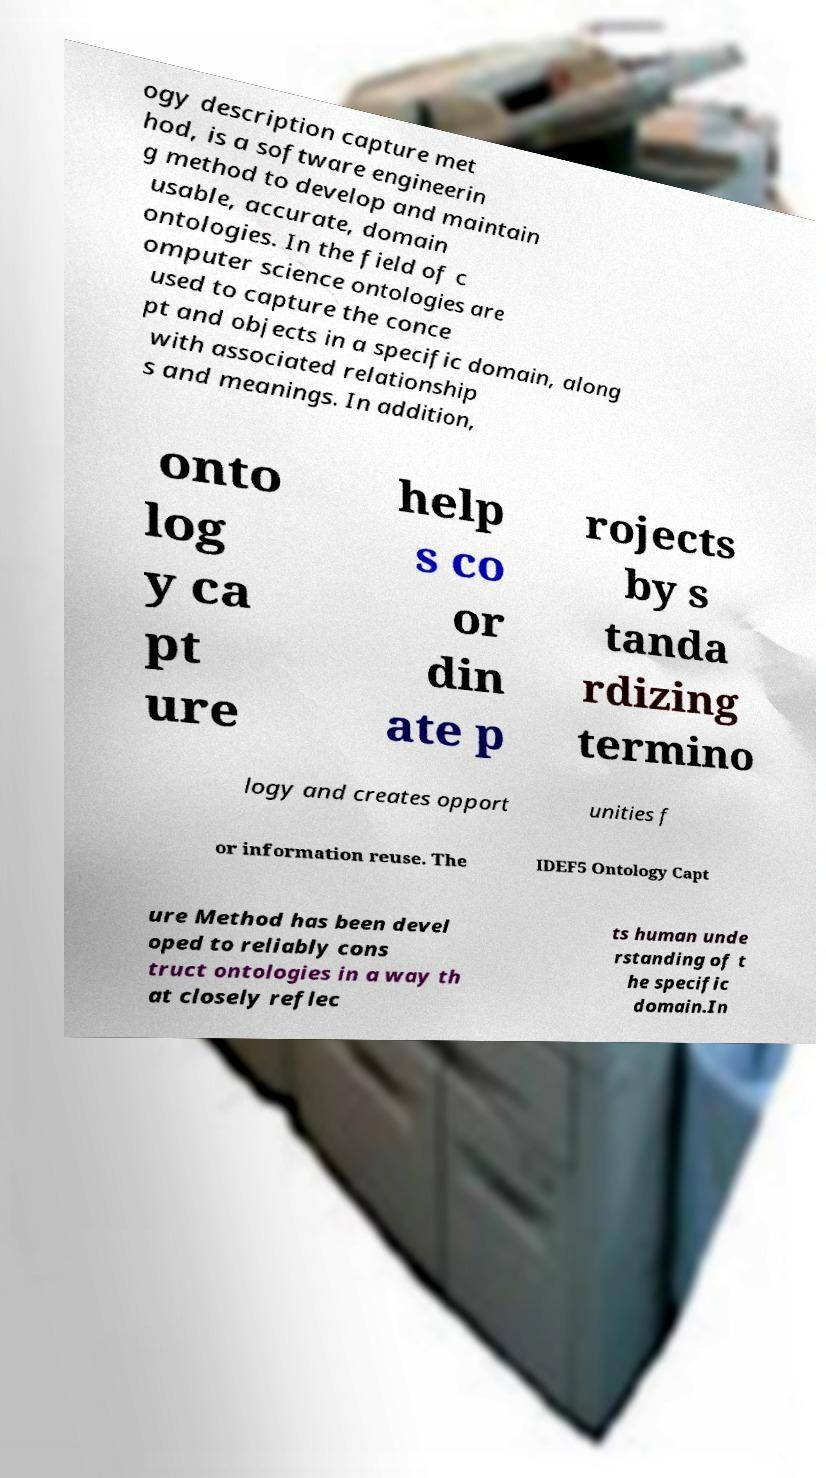Could you assist in decoding the text presented in this image and type it out clearly? ogy description capture met hod, is a software engineerin g method to develop and maintain usable, accurate, domain ontologies. In the field of c omputer science ontologies are used to capture the conce pt and objects in a specific domain, along with associated relationship s and meanings. In addition, onto log y ca pt ure help s co or din ate p rojects by s tanda rdizing termino logy and creates opport unities f or information reuse. The IDEF5 Ontology Capt ure Method has been devel oped to reliably cons truct ontologies in a way th at closely reflec ts human unde rstanding of t he specific domain.In 